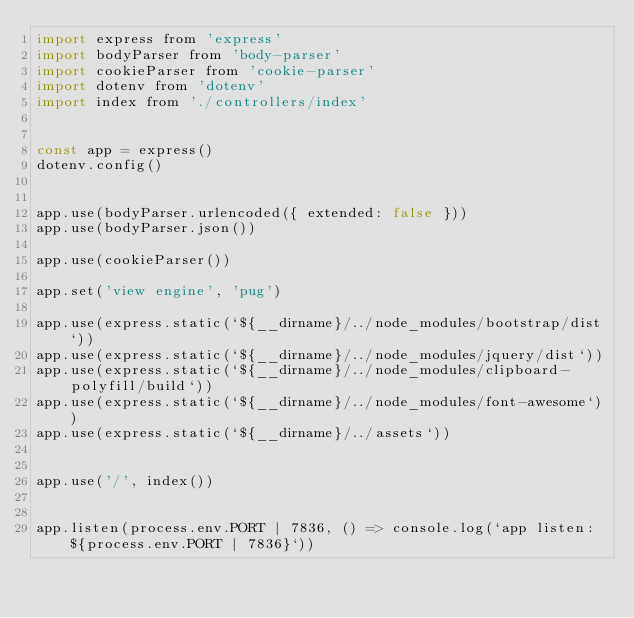<code> <loc_0><loc_0><loc_500><loc_500><_JavaScript_>import express from 'express'
import bodyParser from 'body-parser'
import cookieParser from 'cookie-parser'
import dotenv from 'dotenv'
import index from './controllers/index'


const app = express()
dotenv.config()


app.use(bodyParser.urlencoded({ extended: false }))
app.use(bodyParser.json())

app.use(cookieParser())

app.set('view engine', 'pug')

app.use(express.static(`${__dirname}/../node_modules/bootstrap/dist`))
app.use(express.static(`${__dirname}/../node_modules/jquery/dist`))
app.use(express.static(`${__dirname}/../node_modules/clipboard-polyfill/build`))
app.use(express.static(`${__dirname}/../node_modules/font-awesome`))
app.use(express.static(`${__dirname}/../assets`))


app.use('/', index())


app.listen(process.env.PORT | 7836, () => console.log(`app listen: ${process.env.PORT | 7836}`))
</code> 